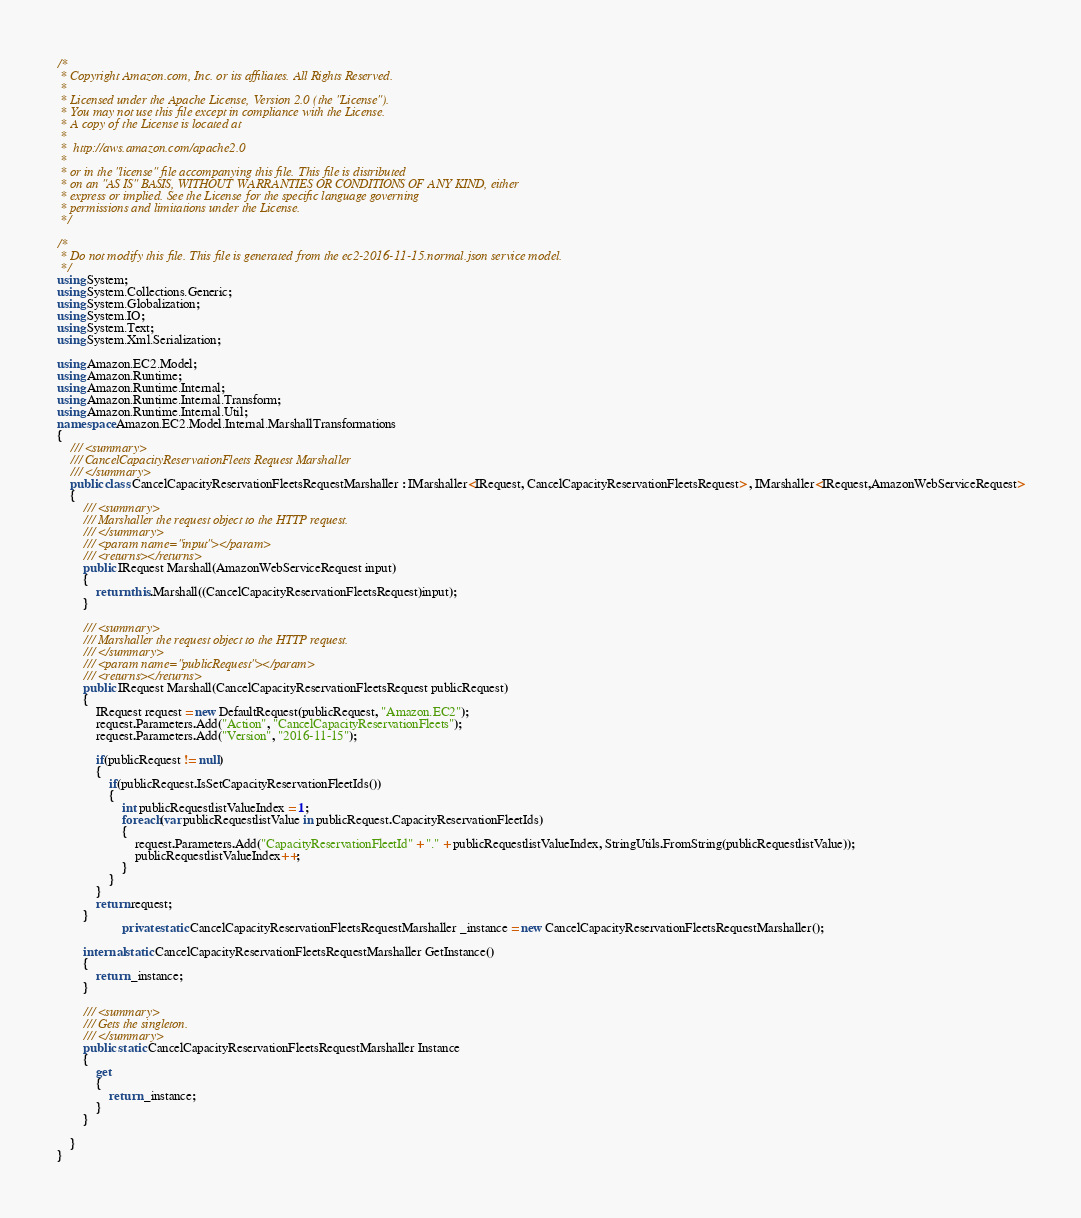Convert code to text. <code><loc_0><loc_0><loc_500><loc_500><_C#_>/*
 * Copyright Amazon.com, Inc. or its affiliates. All Rights Reserved.
 * 
 * Licensed under the Apache License, Version 2.0 (the "License").
 * You may not use this file except in compliance with the License.
 * A copy of the License is located at
 * 
 *  http://aws.amazon.com/apache2.0
 * 
 * or in the "license" file accompanying this file. This file is distributed
 * on an "AS IS" BASIS, WITHOUT WARRANTIES OR CONDITIONS OF ANY KIND, either
 * express or implied. See the License for the specific language governing
 * permissions and limitations under the License.
 */

/*
 * Do not modify this file. This file is generated from the ec2-2016-11-15.normal.json service model.
 */
using System;
using System.Collections.Generic;
using System.Globalization;
using System.IO;
using System.Text;
using System.Xml.Serialization;

using Amazon.EC2.Model;
using Amazon.Runtime;
using Amazon.Runtime.Internal;
using Amazon.Runtime.Internal.Transform;
using Amazon.Runtime.Internal.Util;
namespace Amazon.EC2.Model.Internal.MarshallTransformations
{
    /// <summary>
    /// CancelCapacityReservationFleets Request Marshaller
    /// </summary>       
    public class CancelCapacityReservationFleetsRequestMarshaller : IMarshaller<IRequest, CancelCapacityReservationFleetsRequest> , IMarshaller<IRequest,AmazonWebServiceRequest>
    {
        /// <summary>
        /// Marshaller the request object to the HTTP request.
        /// </summary>  
        /// <param name="input"></param>
        /// <returns></returns>
        public IRequest Marshall(AmazonWebServiceRequest input)
        {
            return this.Marshall((CancelCapacityReservationFleetsRequest)input);
        }
    
        /// <summary>
        /// Marshaller the request object to the HTTP request.
        /// </summary>  
        /// <param name="publicRequest"></param>
        /// <returns></returns>
        public IRequest Marshall(CancelCapacityReservationFleetsRequest publicRequest)
        {
            IRequest request = new DefaultRequest(publicRequest, "Amazon.EC2");
            request.Parameters.Add("Action", "CancelCapacityReservationFleets");
            request.Parameters.Add("Version", "2016-11-15");

            if(publicRequest != null)
            {
                if(publicRequest.IsSetCapacityReservationFleetIds())
                {
                    int publicRequestlistValueIndex = 1;
                    foreach(var publicRequestlistValue in publicRequest.CapacityReservationFleetIds)
                    {
                        request.Parameters.Add("CapacityReservationFleetId" + "." + publicRequestlistValueIndex, StringUtils.FromString(publicRequestlistValue));
                        publicRequestlistValueIndex++;
                    }
                }
            }
            return request;
        }
                    private static CancelCapacityReservationFleetsRequestMarshaller _instance = new CancelCapacityReservationFleetsRequestMarshaller();        

        internal static CancelCapacityReservationFleetsRequestMarshaller GetInstance()
        {
            return _instance;
        }

        /// <summary>
        /// Gets the singleton.
        /// </summary>  
        public static CancelCapacityReservationFleetsRequestMarshaller Instance
        {
            get
            {
                return _instance;
            }
        }

    }
}</code> 